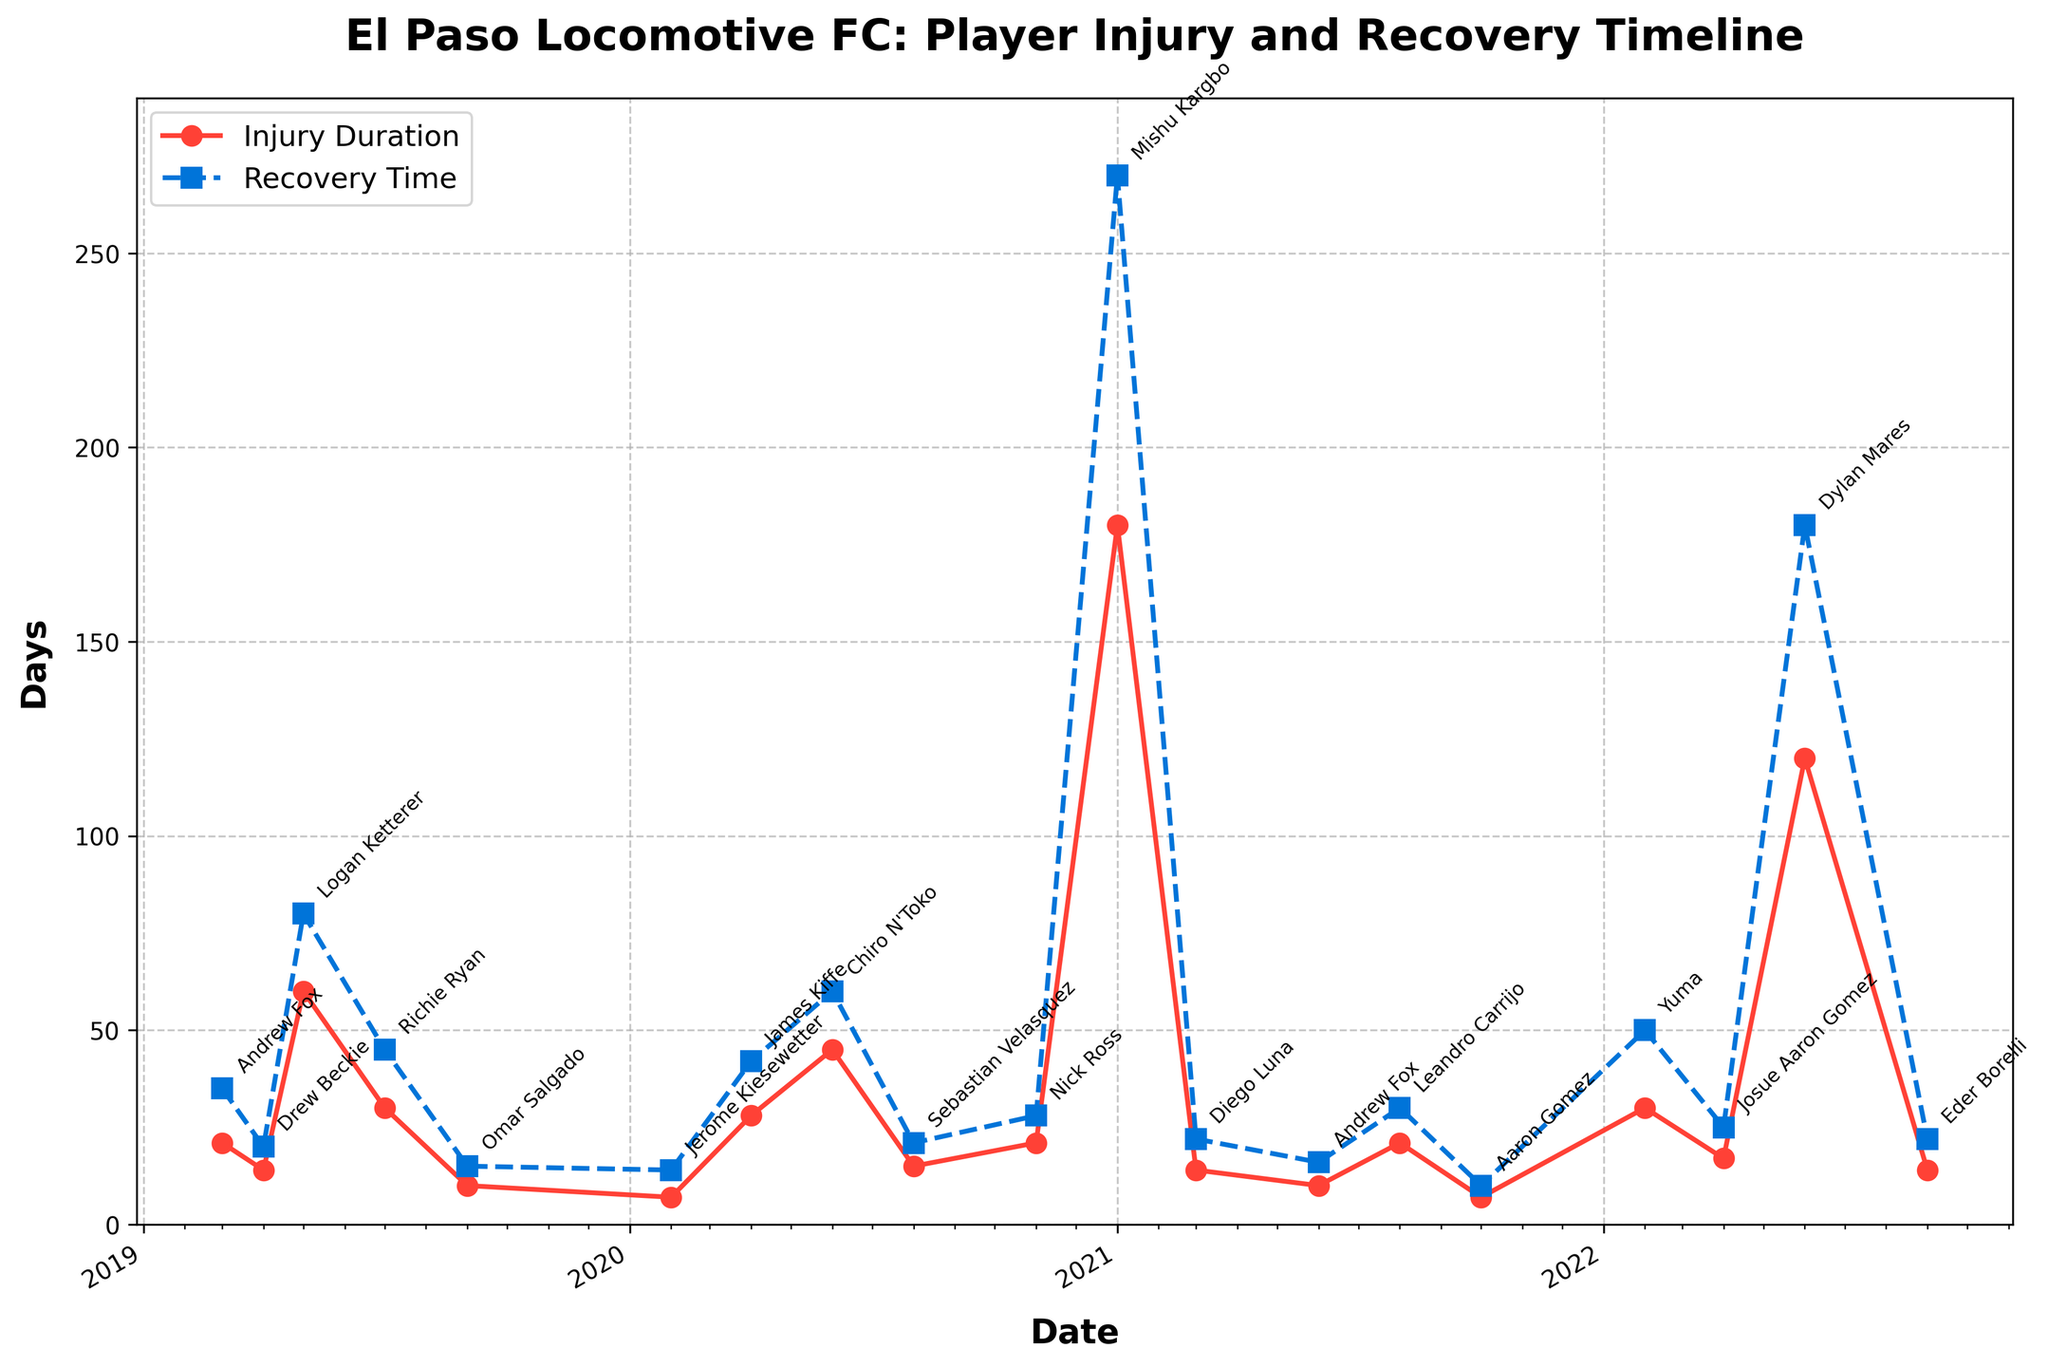What's the title of the figure? Read the title at the top of the figure: "El Paso Locomotive FC: Player Injury and Recovery Timeline"
Answer: El Paso Locomotive FC: Player Injury and Recovery Timeline How many seasons are covered in the figure? Count the number of distinct seasons on the x-axis: 2019, 2020, 2021, and 2022
Answer: 4 Which player had the longest recovery time? Look for the highest point on the "Recovery Time (days)" line: Mishu Kargbo with 270 days
Answer: Mishu Kargbo What's the overall trend in injury duration from 2019 to 2022? Observe the "Injury Duration (days)" line from 2019 to 2022. The durational peaks show varied lengths with notable spikes in 2021 and 2022
Answer: Varied with spikes What's the difference in recovery time between James Kiffe and Richie Ryan? James Kiffe's recovery time is 42 days and Richie Ryan's is 45 days. Calculate the difference: 45 - 42 = 3 days
Answer: 3 days Which season had the highest total recovery times for all players? Sum the recovery times for each season:
2019: 35 + 20 + 80 + 45 + 15 = 195
2020: 14 + 42 + 60 + 21 + 28 = 165
2021: 270 + 22 + 16 + 30 + 10 = 348
2022: 50 + 25 + 180 + 22 = 277
2021 had the highest total
Answer: 2021 Between which two months and years did Andrew Fox have his injuries? Look for "Andrew Fox" on the x-axis; his injuries occurred in March 2019 and June 2021
Answer: March 2019 and June 2021 How does the injury duration for Logan Ketterer compare to Dylan Mares? Logan Ketterer's injury duration is 60 days, Dylan Mares' is 120 days. Dylan Mares' injury duration is longer
Answer: Dylan Mares' is longer What's the difference between the longest and shortest recovery times? The longest recovery time is 270 days (Mishu Kargbo) and the shortest is 10 days (Aaron Gomez), so the difference is 270 - 10 = 260 days
Answer: 260 days How many players had an injury duration of more than 30 days? Locate and count data points on the "Injury Duration (days)" line above 30 days mark. These players are Logan Ketterer, Richie Ryan, Chiro N'Toko, Yuma, Dylan Mares, and Mishu Kargbo
Answer: 6 players 